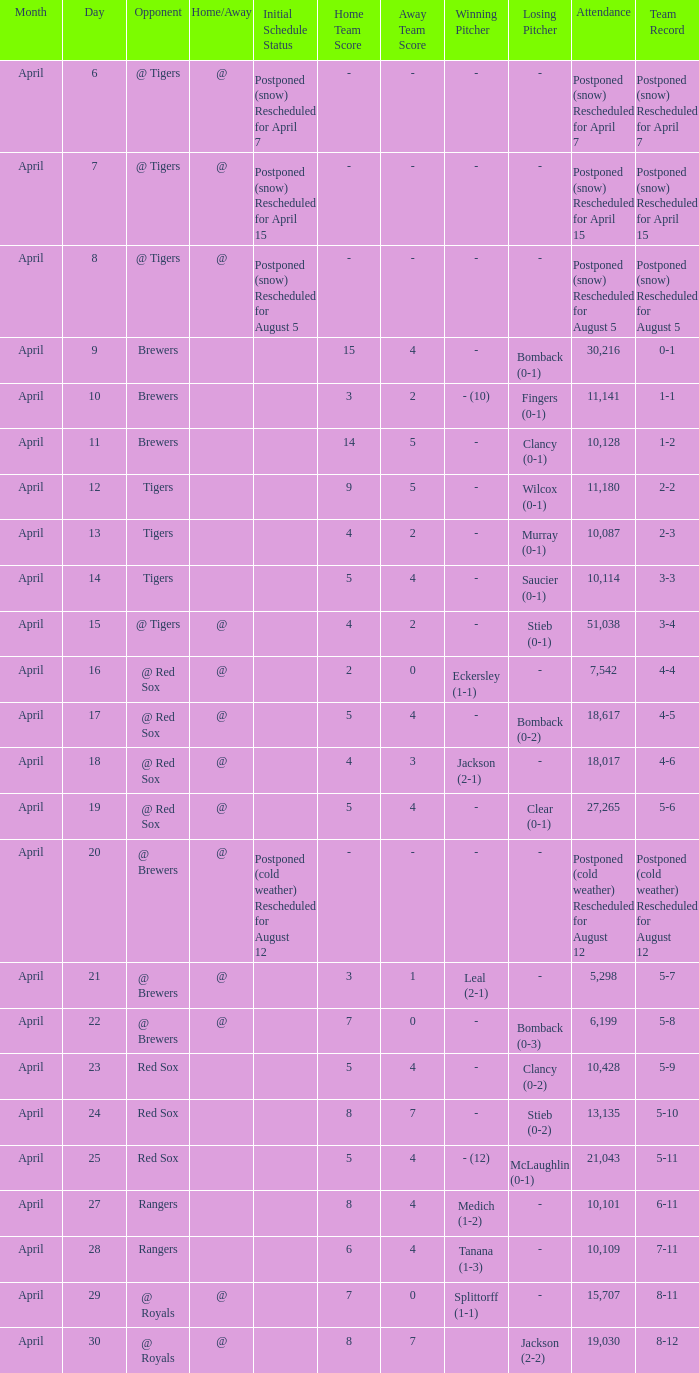What is the record for the game with an attendance of 11,141? 1-1. Could you parse the entire table? {'header': ['Month', 'Day', 'Opponent', 'Home/Away', 'Initial Schedule Status', 'Home Team Score', 'Away Team Score', 'Winning Pitcher', 'Losing Pitcher', 'Attendance', 'Team Record'], 'rows': [['April', '6', '@ Tigers', '@', 'Postponed (snow) Rescheduled for April 7', '-', '-', '-', '-', 'Postponed (snow) Rescheduled for April 7', 'Postponed (snow) Rescheduled for April 7'], ['April', '7', '@ Tigers', '@', 'Postponed (snow) Rescheduled for April 15', '-', '-', '-', '-', 'Postponed (snow) Rescheduled for April 15', 'Postponed (snow) Rescheduled for April 15'], ['April', '8', '@ Tigers', '@', 'Postponed (snow) Rescheduled for August 5', '-', '-', '-', '-', 'Postponed (snow) Rescheduled for August 5', 'Postponed (snow) Rescheduled for August 5'], ['April', '9', 'Brewers', '', '', '15', '4', '-', 'Bomback (0-1)', '30,216', '0-1'], ['April', '10', 'Brewers', '', '', '3', '2', '- (10)', 'Fingers (0-1)', '11,141', '1-1'], ['April', '11', 'Brewers', '', '', '14', '5', '-', 'Clancy (0-1)', '10,128', '1-2'], ['April', '12', 'Tigers', '', '', '9', '5', '-', 'Wilcox (0-1)', '11,180', '2-2'], ['April', '13', 'Tigers', '', '', '4', '2', '-', 'Murray (0-1)', '10,087', '2-3'], ['April', '14', 'Tigers', '', '', '5', '4', '-', 'Saucier (0-1)', '10,114', '3-3'], ['April', '15', '@ Tigers', '@', '', '4', '2', '-', 'Stieb (0-1)', '51,038', '3-4'], ['April', '16', '@ Red Sox', '@', '', '2', '0', 'Eckersley (1-1)', '-', '7,542', '4-4'], ['April', '17', '@ Red Sox', '@', '', '5', '4', '-', 'Bomback (0-2)', '18,617', '4-5'], ['April', '18', '@ Red Sox', '@', '', '4', '3', 'Jackson (2-1)', '-', '18,017', '4-6'], ['April', '19', '@ Red Sox', '@', '', '5', '4', '-', 'Clear (0-1)', '27,265', '5-6'], ['April', '20', '@ Brewers', '@', 'Postponed (cold weather) Rescheduled for August 12', '-', '-', '-', '-', 'Postponed (cold weather) Rescheduled for August 12', 'Postponed (cold weather) Rescheduled for August 12'], ['April', '21', '@ Brewers', '@', '', '3', '1', 'Leal (2-1)', '-', '5,298', '5-7'], ['April', '22', '@ Brewers', '@', '', '7', '0', '-', 'Bomback (0-3)', '6,199', '5-8'], ['April', '23', 'Red Sox', '', '', '5', '4', '-', 'Clancy (0-2)', '10,428', '5-9'], ['April', '24', 'Red Sox', '', '', '8', '7', '-', 'Stieb (0-2)', '13,135', '5-10'], ['April', '25', 'Red Sox', '', '', '5', '4', '- (12)', 'McLaughlin (0-1)', '21,043', '5-11'], ['April', '27', 'Rangers', '', '', '8', '4', 'Medich (1-2)', '-', '10,101', '6-11'], ['April', '28', 'Rangers', '', '', '6', '4', 'Tanana (1-3)', '-', '10,109', '7-11'], ['April', '29', '@ Royals', '@', '', '7', '0', 'Splittorff (1-1)', '-', '15,707', '8-11'], ['April', '30', '@ Royals', '@', '', '8', '7', '', 'Jackson (2-2)', '19,030', '8-12']]} 